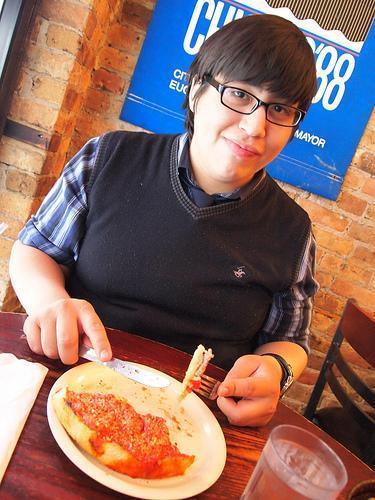How many people is here?
Give a very brief answer. 1. How many numbers can you see whole on the poster?
Give a very brief answer. 1. 